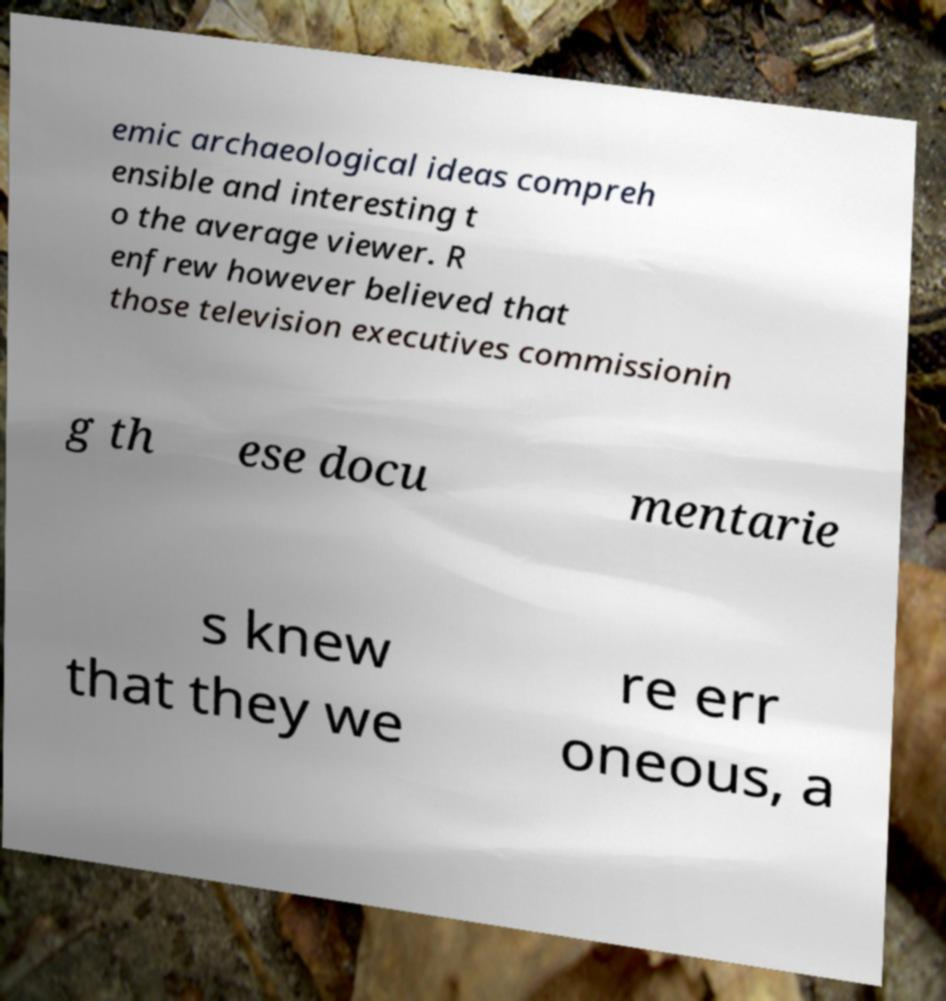For documentation purposes, I need the text within this image transcribed. Could you provide that? emic archaeological ideas compreh ensible and interesting t o the average viewer. R enfrew however believed that those television executives commissionin g th ese docu mentarie s knew that they we re err oneous, a 